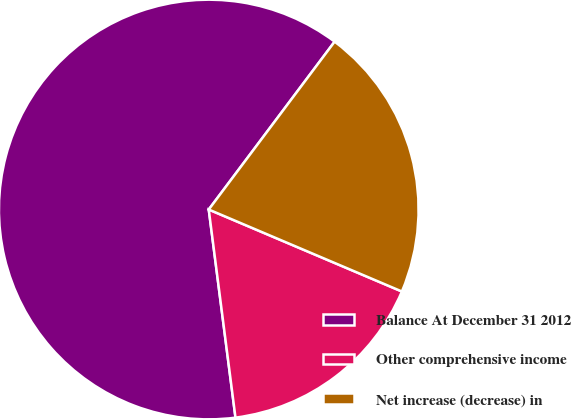Convert chart. <chart><loc_0><loc_0><loc_500><loc_500><pie_chart><fcel>Balance At December 31 2012<fcel>Other comprehensive income<fcel>Net increase (decrease) in<nl><fcel>62.28%<fcel>16.58%<fcel>21.15%<nl></chart> 